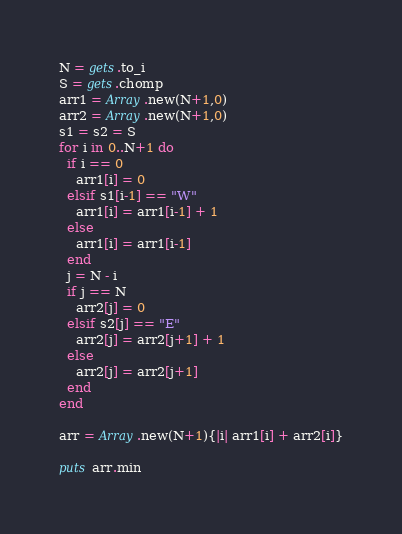Convert code to text. <code><loc_0><loc_0><loc_500><loc_500><_Ruby_>N = gets.to_i
S = gets.chomp
arr1 = Array.new(N+1,0)
arr2 = Array.new(N+1,0)
s1 = s2 = S
for i in 0..N+1 do
  if i == 0
    arr1[i] = 0
  elsif s1[i-1] == "W"
    arr1[i] = arr1[i-1] + 1
  else
    arr1[i] = arr1[i-1]
  end
  j = N - i
  if j == N
    arr2[j] = 0
  elsif s2[j] == "E"
    arr2[j] = arr2[j+1] + 1
  else
    arr2[j] = arr2[j+1]
  end
end

arr = Array.new(N+1){|i| arr1[i] + arr2[i]}

puts arr.min</code> 